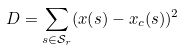<formula> <loc_0><loc_0><loc_500><loc_500>D = \sum _ { s \in \mathcal { S } _ { r } } ( x ( s ) - x _ { c } ( s ) ) ^ { 2 }</formula> 